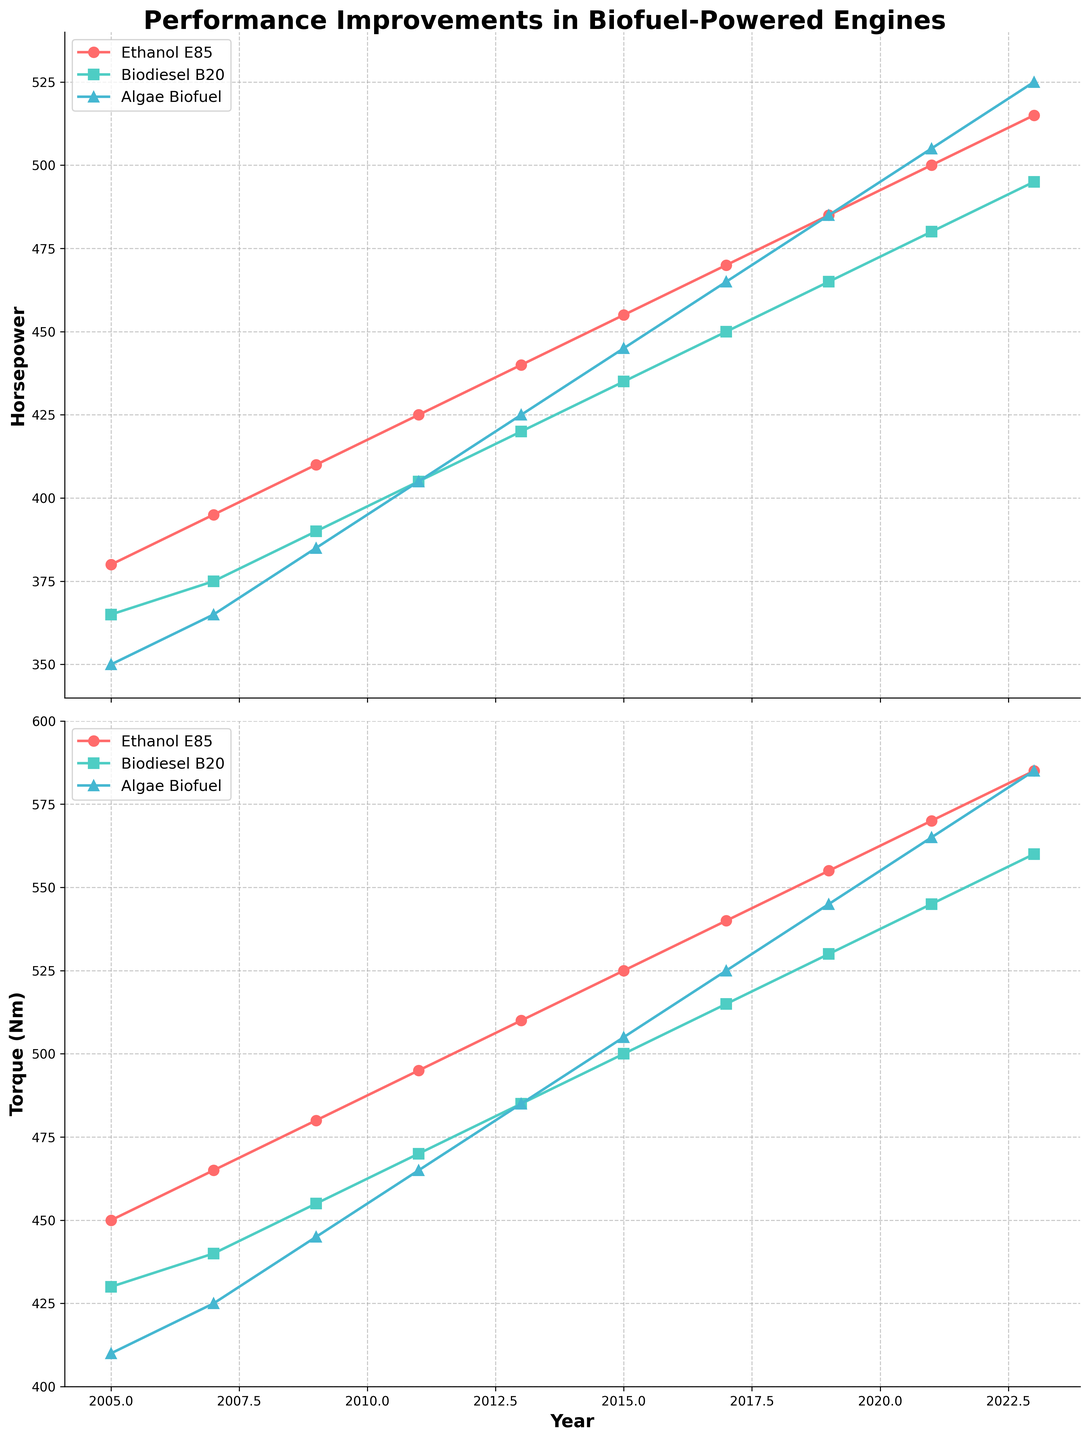What is the horsepower improvement for Ethanol E85 from 2005 to 2023? Start with 2005 HP for Ethanol E85 which is 380, then look at 2023 HP which is 515. Calculate the difference: 515 - 380 = 135
Answer: 135 HP Which biofuel has the highest torque in 2023? Look at the Torque values for 2023 across all three biofuels. Ethanol E85 has 585 Nm, Biodiesel B20 has 560 Nm, and Algae Biofuel has 585 Nm. Both Ethanol E85 and Algae Biofuel have the highest torque.
Answer: Ethanol E85 and Algae Biofuel How much more torque does Biodiesel B20 have in 2023 compared to 2011? Biodiesel B20 Torque in 2011 is 470 Nm, and in 2023 it is 560 Nm. Calculate the difference: 560 - 470 = 90
Answer: 90 Nm What trend do you observe for Algae Biofuel horsepower from 2005 to 2023? Observe the Algae Biofuel HP values from 2005 (350) to 2023 (525). There is a consistent increase over the years.
Answer: Increasing trend Between which years did Ethanol E85 show the largest increase in horsepower? Check consecutive years for Ethanol E85 HP and calculate the differences. Between 2011 and 2013: 440 - 425 = 15 HP, and others show the trend is consistent. The largest increase is between 2011 (425) and 2013 (440) with an increase of 15 HP.
Answer: 2011 to 2013 How does the horsepower for Biodiesel B20 in 2015 compare to Ethanol E85 in 2005? Biodiesel B20 HP in 2015 is 435, while Ethanol E85 HP in 2005 is 380. 435 is greater than 380.
Answer: Biodiesel B20 in 2015 has higher HP Which biofuel had the lowest torque in 2005? Look at torque values for 2005 for all biofuels. Ethanol E85 is 450 Nm, Biodiesel B20 is 430 Nm, and Algae Biofuel is 410 Nm. Algae Biofuel has the lowest torque.
Answer: Algae Biofuel Between 2017 and 2019, which biofuel had the smallest increase in horsepower? Calculate the HP differences for each biofuel: Ethanol E85 (485 - 470 = 15), Biodiesel B20 (465 - 450 = 15), and Algae Biofuel (485 - 465 = 20). Both Ethanol E85 and Biodiesel B20 have the smallest increase of 15 HP.
Answer: Ethanol E85 and Biodiesel B20 On the plot, which biofuel's torque line has the steepest upward slope overall? Visually compare the slopes of the torque lines for Ethanol E85, Biodiesel B20, and Algae Biofuel. Ethanol E85 shows the steepest upward slope.
Answer: Ethanol E85 How consistent was the increase in horsepower for each biofuel over the observed years? Look at the plot lines for HP of each biofuel from 2005 to 2023. All biofuels show a consistent increasing trend without significant drops or plateaus.
Answer: All biofuels show a consistent increase 